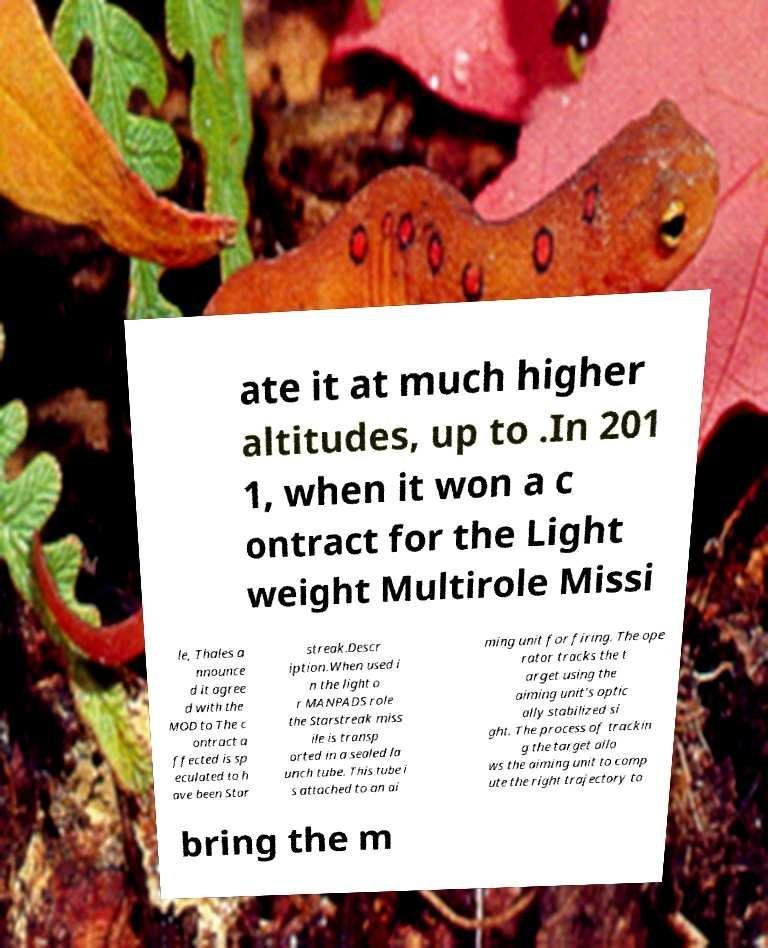Can you read and provide the text displayed in the image?This photo seems to have some interesting text. Can you extract and type it out for me? ate it at much higher altitudes, up to .In 201 1, when it won a c ontract for the Light weight Multirole Missi le, Thales a nnounce d it agree d with the MOD to The c ontract a ffected is sp eculated to h ave been Star streak.Descr iption.When used i n the light o r MANPADS role the Starstreak miss ile is transp orted in a sealed la unch tube. This tube i s attached to an ai ming unit for firing. The ope rator tracks the t arget using the aiming unit's optic ally stabilized si ght. The process of trackin g the target allo ws the aiming unit to comp ute the right trajectory to bring the m 